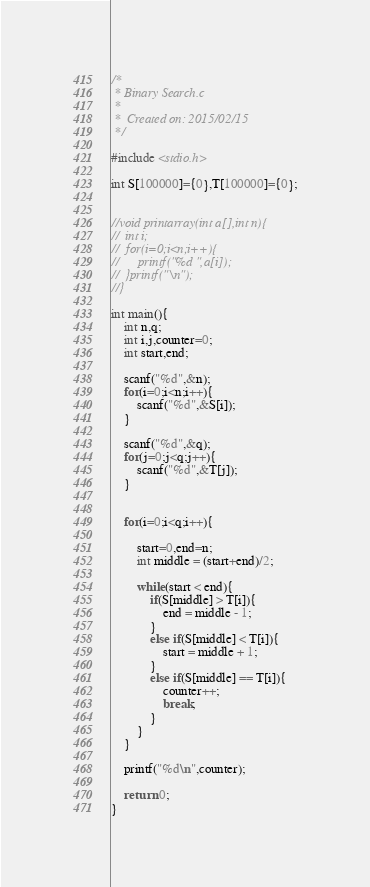<code> <loc_0><loc_0><loc_500><loc_500><_C_>/*
 * Binary Search.c
 *
 *  Created on: 2015/02/15
 */

#include <stdio.h>

int S[100000]={0},T[100000]={0};


//void printarray(int a[],int n){
//	int i;
//	for(i=0;i<n;i++){
//		printf("%d ",a[i]);
//	}printf("\n");
//}

int main(){
	int n,q;
	int i,j,counter=0;
	int start,end;

	scanf("%d",&n);
	for(i=0;i<n;i++){
		scanf("%d",&S[i]);
	}

	scanf("%d",&q);
	for(j=0;j<q;j++){
		scanf("%d",&T[j]);
	}


	for(i=0;i<q;i++){

		start=0,end=n;
		int middle = (start+end)/2;

		while(start < end){
			if(S[middle] > T[i]){
				end = middle - 1;
			}
			else if(S[middle] < T[i]){
				start = middle + 1;
			}
			else if(S[middle] == T[i]){
				counter++;
				break;
			}
		}
	}

	printf("%d\n",counter);

	return 0;
}</code> 